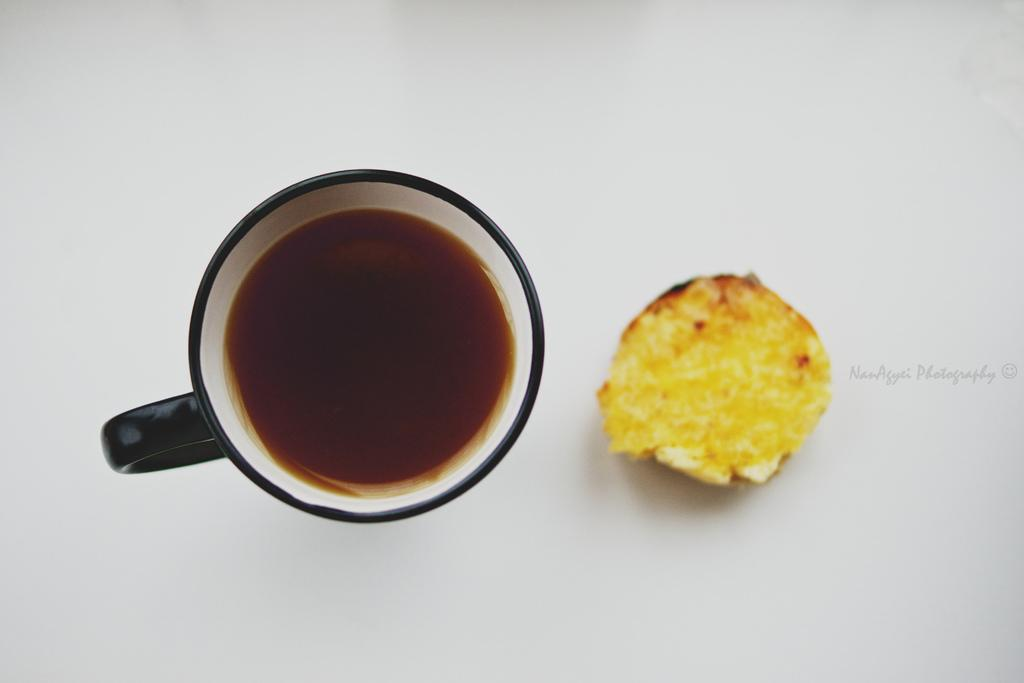What is the color of the surface in the image? The surface in the image is white. What is placed on the white surface? There is a cup on the white surface. What is inside the cup? The cup contains a brown liquid. Can you describe the yellow food item in the image? There is a yellow food item in the image, but its specific characteristics are not mentioned in the provided facts. What type of spark can be seen coming from the cup in the image? There is no spark present in the image; it features a cup with a brown liquid on a white surface. What kind of noise is associated with the yellow food item in the image? There is no noise associated with the yellow food item in the image, as it is not described in detail. 